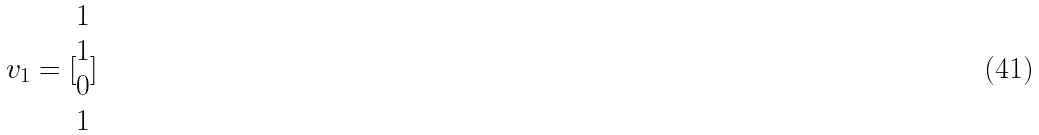Convert formula to latex. <formula><loc_0><loc_0><loc_500><loc_500>v _ { 1 } = [ \begin{matrix} 1 \\ 1 \\ 0 \\ 1 \end{matrix} ]</formula> 